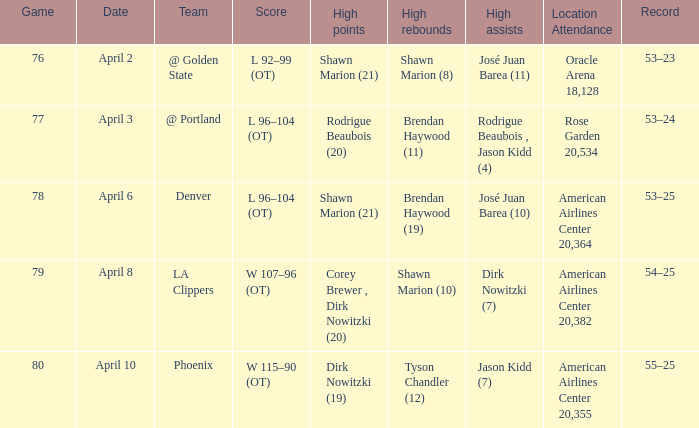What is the game number played on April 3? 77.0. 